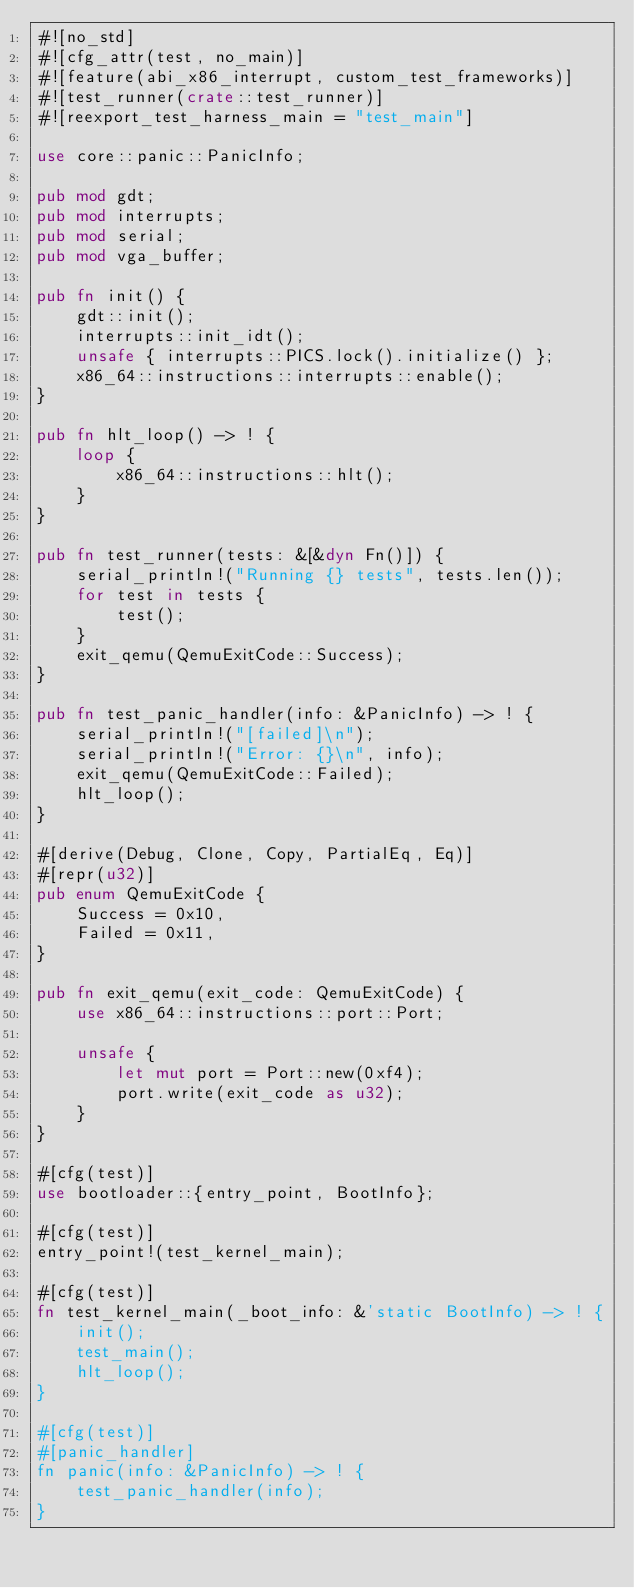<code> <loc_0><loc_0><loc_500><loc_500><_Rust_>#![no_std]
#![cfg_attr(test, no_main)]
#![feature(abi_x86_interrupt, custom_test_frameworks)]
#![test_runner(crate::test_runner)]
#![reexport_test_harness_main = "test_main"]

use core::panic::PanicInfo;

pub mod gdt;
pub mod interrupts;
pub mod serial;
pub mod vga_buffer;

pub fn init() {
    gdt::init();
    interrupts::init_idt();
    unsafe { interrupts::PICS.lock().initialize() };
    x86_64::instructions::interrupts::enable();
}

pub fn hlt_loop() -> ! {
    loop {
        x86_64::instructions::hlt();
    }
}

pub fn test_runner(tests: &[&dyn Fn()]) {
    serial_println!("Running {} tests", tests.len());
    for test in tests {
        test();
    }
    exit_qemu(QemuExitCode::Success);
}

pub fn test_panic_handler(info: &PanicInfo) -> ! {
    serial_println!("[failed]\n");
    serial_println!("Error: {}\n", info);
    exit_qemu(QemuExitCode::Failed);
    hlt_loop();
}

#[derive(Debug, Clone, Copy, PartialEq, Eq)]
#[repr(u32)]
pub enum QemuExitCode {
    Success = 0x10,
    Failed = 0x11,
}

pub fn exit_qemu(exit_code: QemuExitCode) {
    use x86_64::instructions::port::Port;

    unsafe {
        let mut port = Port::new(0xf4);
        port.write(exit_code as u32);
    }
}

#[cfg(test)]
use bootloader::{entry_point, BootInfo};

#[cfg(test)]
entry_point!(test_kernel_main);

#[cfg(test)]
fn test_kernel_main(_boot_info: &'static BootInfo) -> ! {
    init();
    test_main();
    hlt_loop();
}

#[cfg(test)]
#[panic_handler]
fn panic(info: &PanicInfo) -> ! {
    test_panic_handler(info);
}
</code> 